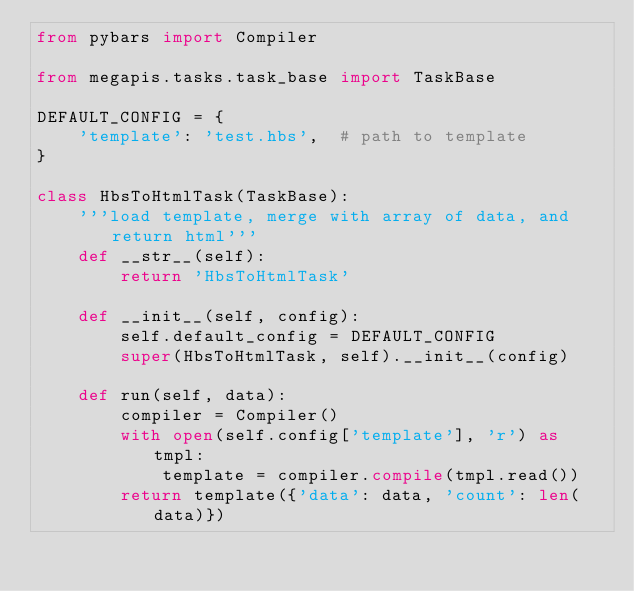<code> <loc_0><loc_0><loc_500><loc_500><_Python_>from pybars import Compiler

from megapis.tasks.task_base import TaskBase

DEFAULT_CONFIG = {
    'template': 'test.hbs',  # path to template
}

class HbsToHtmlTask(TaskBase):
    '''load template, merge with array of data, and return html'''
    def __str__(self):
        return 'HbsToHtmlTask'

    def __init__(self, config):
        self.default_config = DEFAULT_CONFIG
        super(HbsToHtmlTask, self).__init__(config)

    def run(self, data):
        compiler = Compiler()
        with open(self.config['template'], 'r') as tmpl:
            template = compiler.compile(tmpl.read())
        return template({'data': data, 'count': len(data)})
</code> 